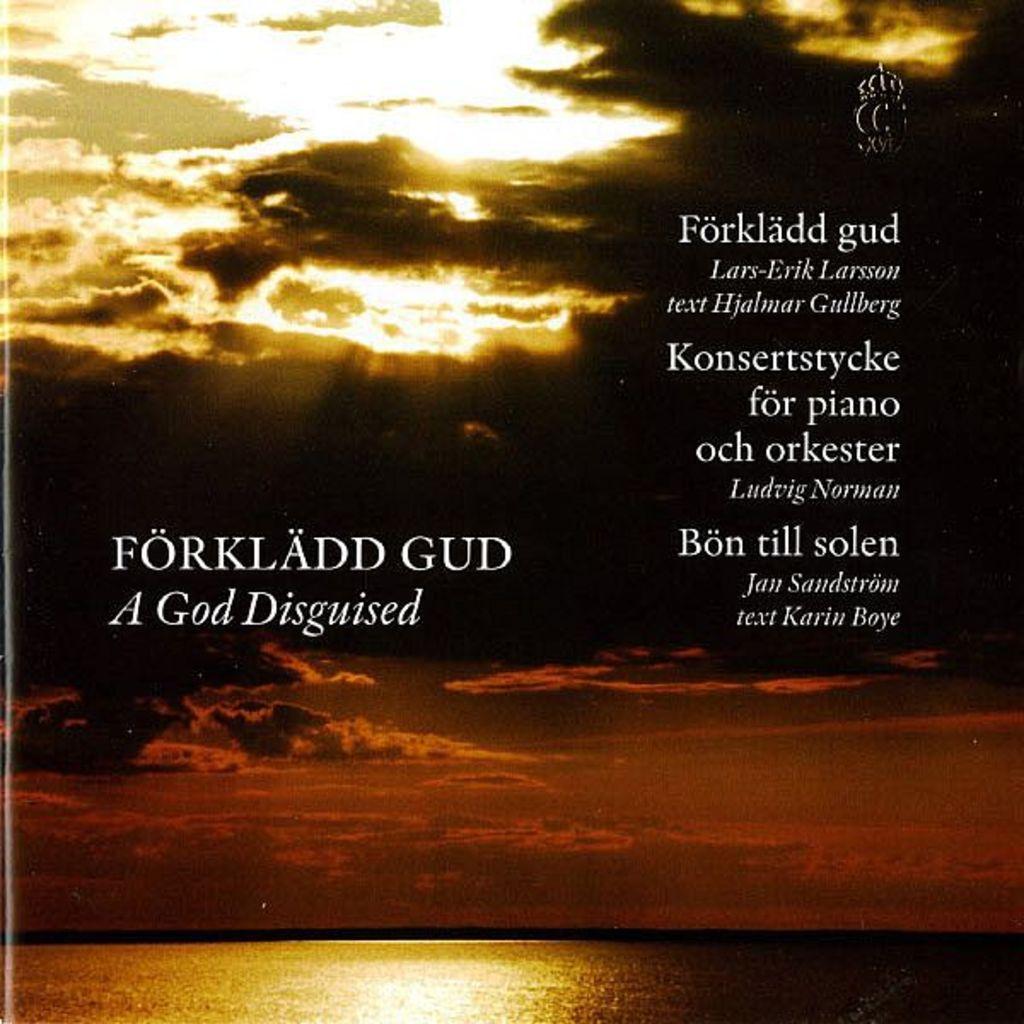Does forkladd gud translate to a god disguised?
Provide a short and direct response. Yes. 